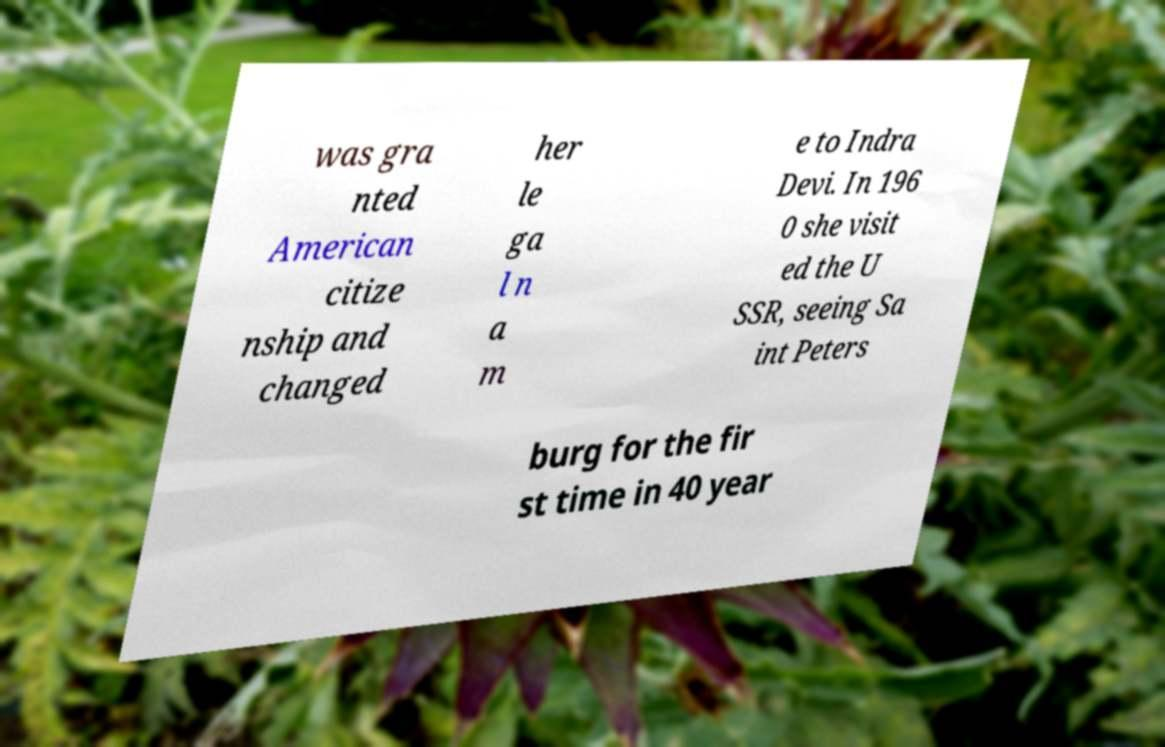Could you assist in decoding the text presented in this image and type it out clearly? was gra nted American citize nship and changed her le ga l n a m e to Indra Devi. In 196 0 she visit ed the U SSR, seeing Sa int Peters burg for the fir st time in 40 year 